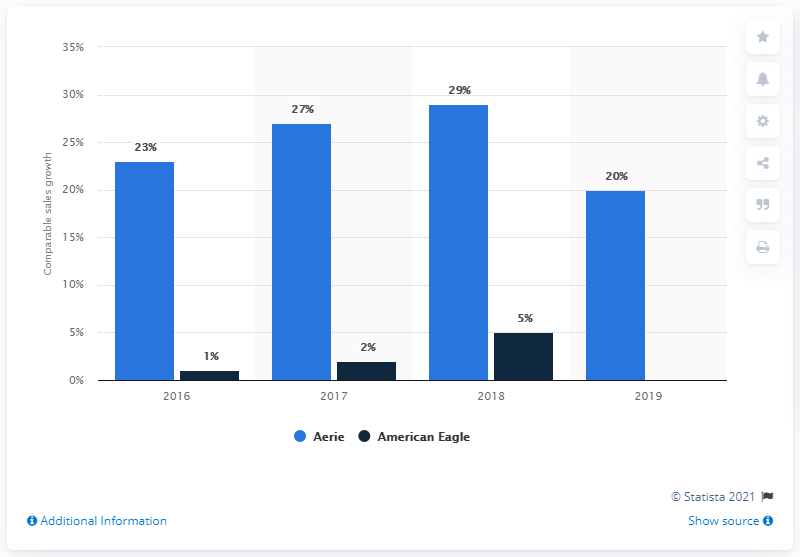Compared to American Eagle, how did Aerie perform in terms of growth? Comparatively, Aerie had stronger sales growth than American Eagle in most of the years shown. In particular, 2018 stands out when Aerie grew by 29%, while American Eagle had much lower growth at 5%. 